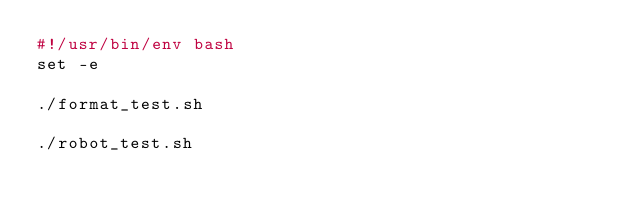Convert code to text. <code><loc_0><loc_0><loc_500><loc_500><_Bash_>#!/usr/bin/env bash
set -e

./format_test.sh

./robot_test.sh
</code> 